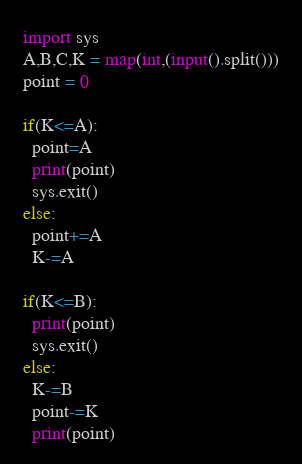<code> <loc_0><loc_0><loc_500><loc_500><_Python_>import sys
A,B,C,K = map(int,(input().split()))
point = 0

if(K<=A):
  point=A
  print(point)
  sys.exit()
else:
  point+=A
  K-=A

if(K<=B):
  print(point)
  sys.exit()
else:
  K-=B
  point-=K
  print(point)</code> 